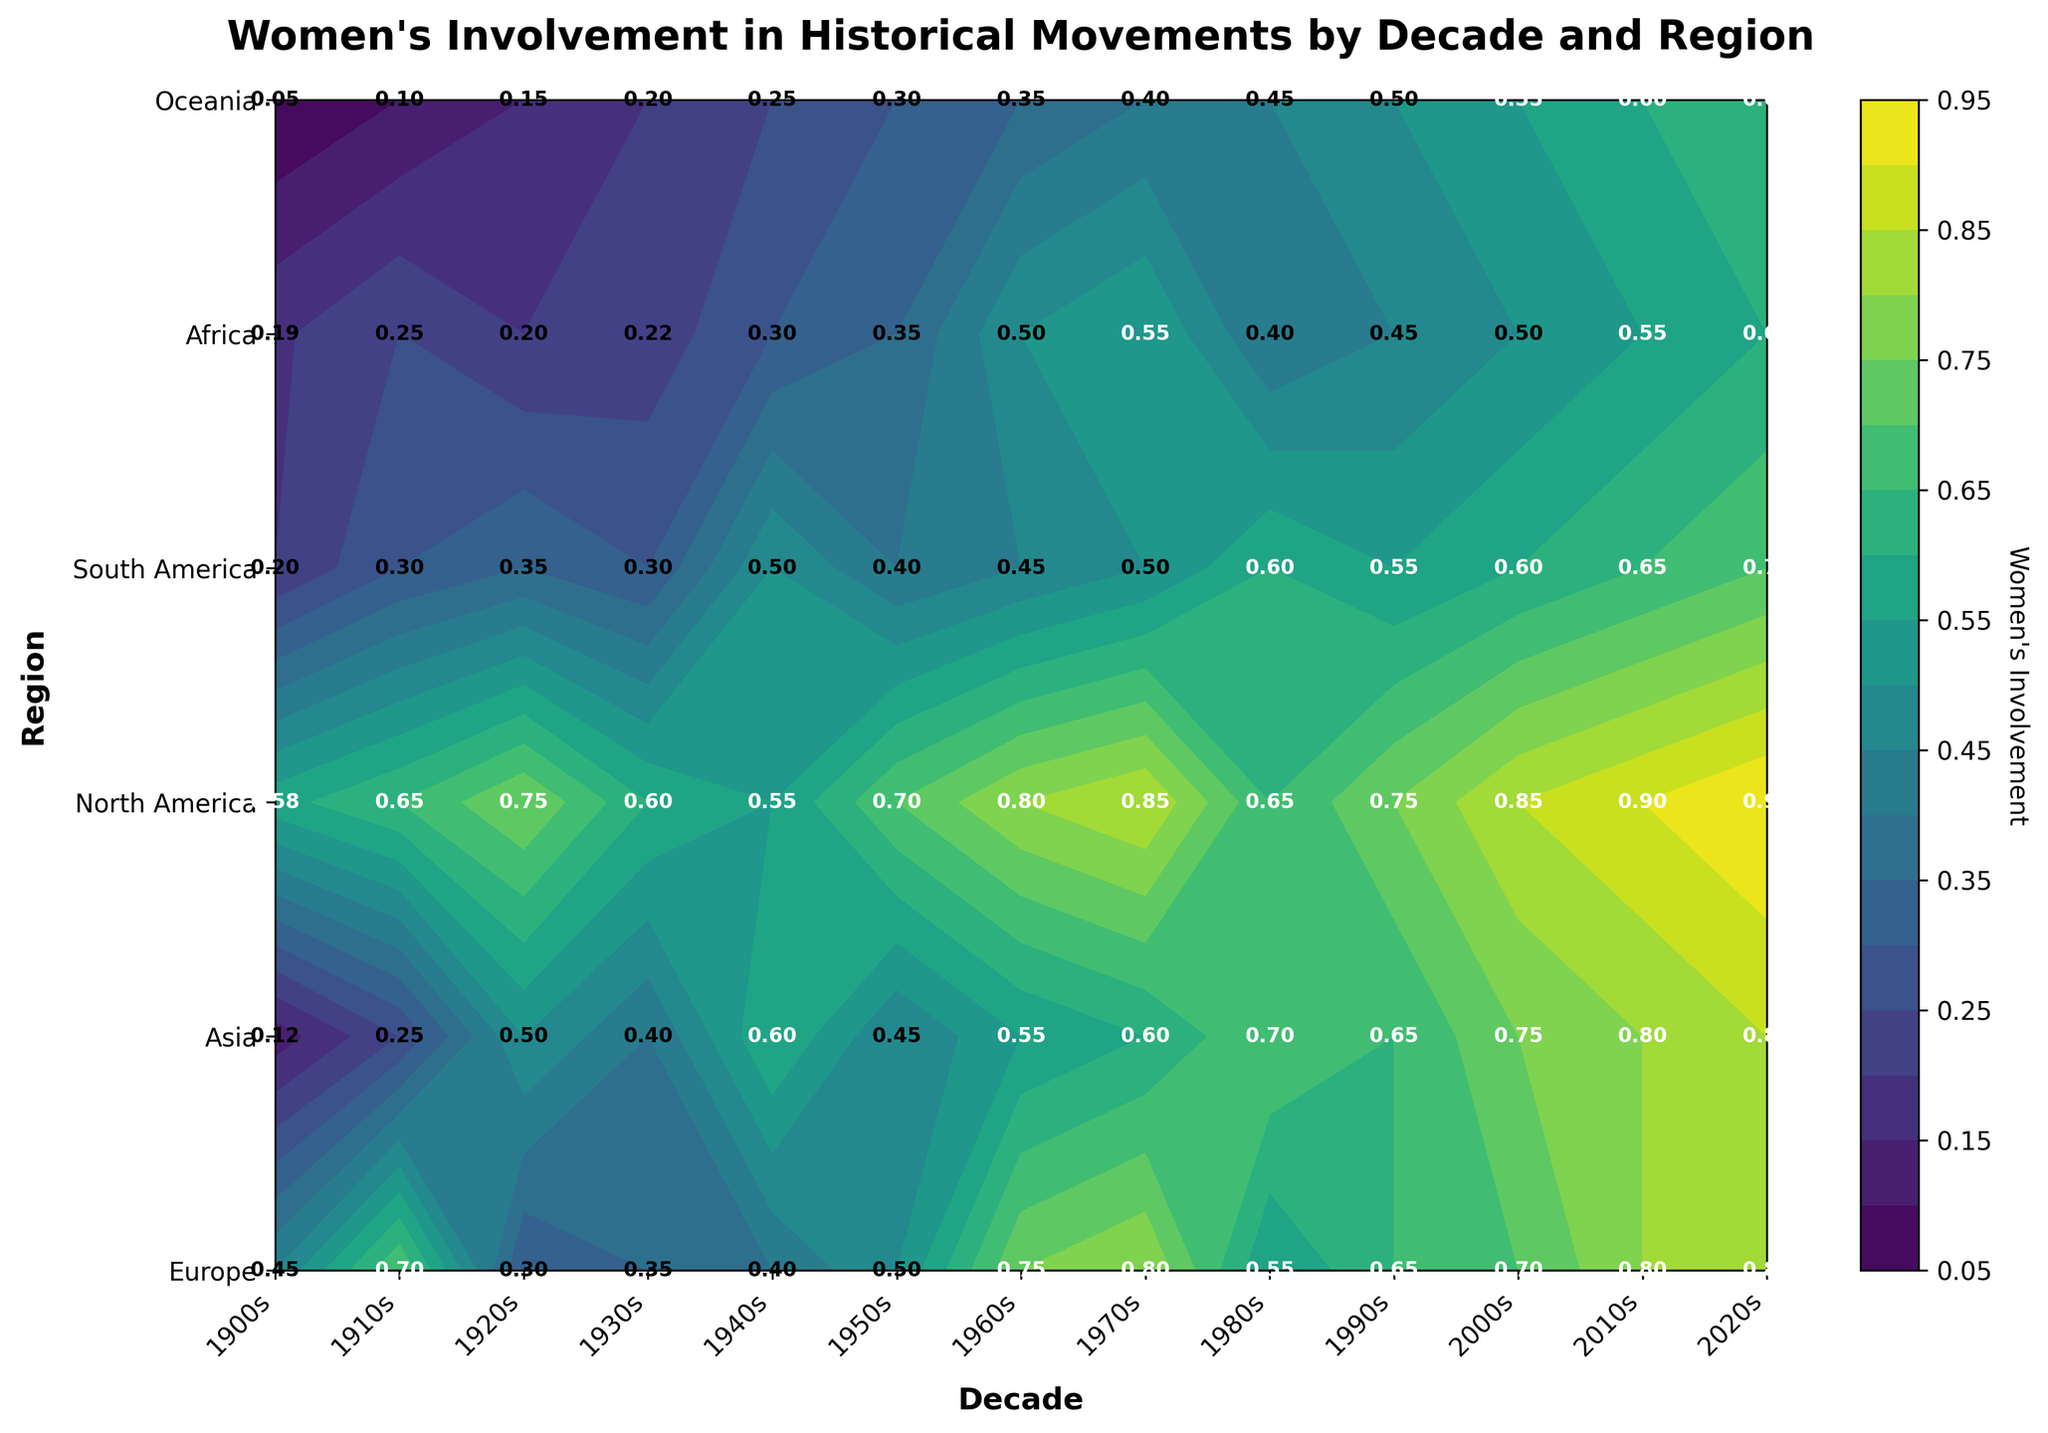What regions are involved in the MeToo Movement in the 2010s? From the contour plot, find the label "MeToo Movement" on the y-axis (regions) and trace along to the value corresponding to the 2010s on the x-axis. The regions involved are labeled directly at these intersections.
Answer: Europe, Asia, North America, South America, Africa, Oceania What is the decade with the highest women's involvement in Civil Rights movements? Trace the Civil Rights movement along its row and compare the values under each decade on the x-axis. The highest value will indicate the decade with the highest involvement.
Answer: 1920s How did women's involvement in Feminist Movement in Europe change from the 1960s to the 1970s? Locate the values for Europe under the "Feminist Movement" row for both the 1960s and the 1970s. Compare these two values to determine the change.
Answer: Increase from 0.75 to 0.80 Which decade had the highest women's involvement in Climate Justice across all regions combined? For each decade, sum up the values across all regions for Climate Justice and compare these sums. The highest sum will indicate the decade with the highest overall involvement.
Answer: 2020s Compare women's involvement in Women's Liberation movement between Africa and Oceania in the 1950s. Which region had a higher involvement? Locate the values for Women's Liberation in the 1950s for both Africa and Oceania. Compare these two values directly to see which is higher.
Answer: Oceania with 0.30 What is the women's involvement in LGBTQ+ Rights in Asia in the 2000s? Find the value at the intersection of the LGBTQ+ Rights row and the "Asia" column under the 2000s.
Answer: 0.75 How did women's involvement in historical movements change in North America from the 1940s to the 1950s? Compare the involvement values for North America between the 1940s (Anti-War) and the 1950s (Women’s Liberation).
Answer: Increased from 0.55 to 0.70 Which region shows the least involvement in Environmentalism in the 1980s? Find the values for Environmentalism in the 1980s across all regions and identify the lowest one.
Answer: Europe with 0.55 What movement in the 1910s had the highest women's involvement in Asia? Identify the highest value in the Asia column under the 1910s decade and correspond it to the movement in that row.
Answer: Suffragette Movement with 0.25 